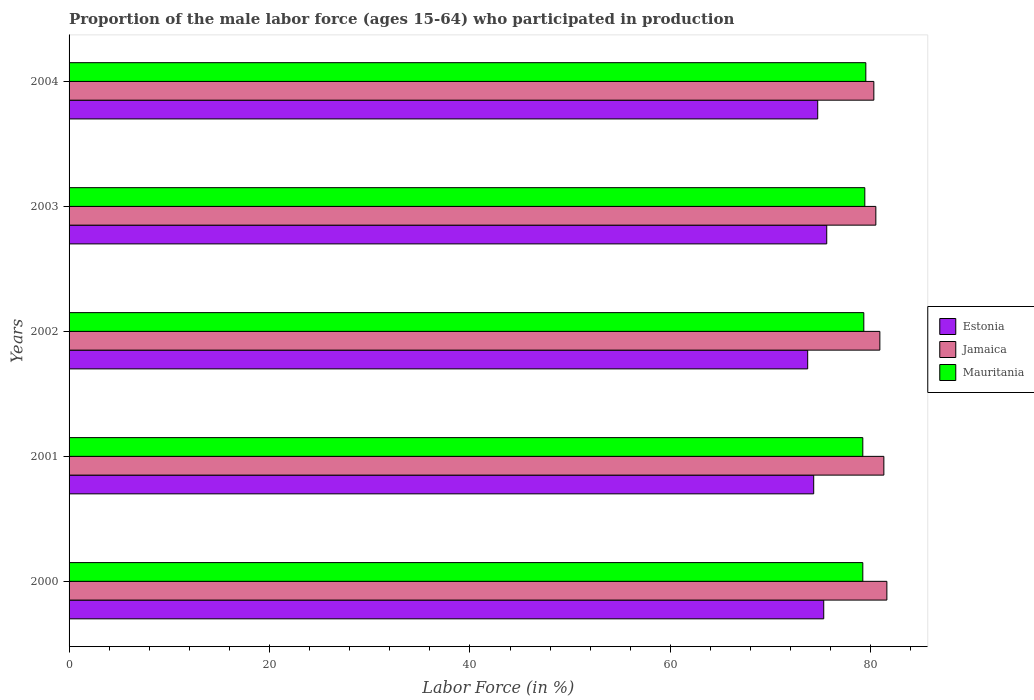How many different coloured bars are there?
Give a very brief answer. 3. How many groups of bars are there?
Offer a terse response. 5. How many bars are there on the 5th tick from the bottom?
Give a very brief answer. 3. What is the label of the 5th group of bars from the top?
Offer a terse response. 2000. What is the proportion of the male labor force who participated in production in Estonia in 2003?
Offer a very short reply. 75.6. Across all years, what is the maximum proportion of the male labor force who participated in production in Estonia?
Provide a succinct answer. 75.6. Across all years, what is the minimum proportion of the male labor force who participated in production in Estonia?
Your response must be concise. 73.7. In which year was the proportion of the male labor force who participated in production in Mauritania minimum?
Offer a very short reply. 2000. What is the total proportion of the male labor force who participated in production in Estonia in the graph?
Give a very brief answer. 373.6. What is the difference between the proportion of the male labor force who participated in production in Estonia in 2000 and that in 2002?
Give a very brief answer. 1.6. What is the difference between the proportion of the male labor force who participated in production in Mauritania in 2004 and the proportion of the male labor force who participated in production in Estonia in 2003?
Your response must be concise. 3.9. What is the average proportion of the male labor force who participated in production in Jamaica per year?
Make the answer very short. 80.92. In the year 2004, what is the difference between the proportion of the male labor force who participated in production in Jamaica and proportion of the male labor force who participated in production in Estonia?
Keep it short and to the point. 5.6. In how many years, is the proportion of the male labor force who participated in production in Jamaica greater than 32 %?
Your answer should be very brief. 5. What is the ratio of the proportion of the male labor force who participated in production in Estonia in 2000 to that in 2003?
Provide a short and direct response. 1. Is the proportion of the male labor force who participated in production in Estonia in 2000 less than that in 2003?
Your response must be concise. Yes. What is the difference between the highest and the second highest proportion of the male labor force who participated in production in Jamaica?
Offer a terse response. 0.3. What is the difference between the highest and the lowest proportion of the male labor force who participated in production in Jamaica?
Your answer should be very brief. 1.3. In how many years, is the proportion of the male labor force who participated in production in Jamaica greater than the average proportion of the male labor force who participated in production in Jamaica taken over all years?
Your response must be concise. 2. What does the 2nd bar from the top in 2000 represents?
Offer a terse response. Jamaica. What does the 1st bar from the bottom in 2003 represents?
Keep it short and to the point. Estonia. Is it the case that in every year, the sum of the proportion of the male labor force who participated in production in Mauritania and proportion of the male labor force who participated in production in Estonia is greater than the proportion of the male labor force who participated in production in Jamaica?
Keep it short and to the point. Yes. How many bars are there?
Your response must be concise. 15. Does the graph contain grids?
Your answer should be compact. No. How are the legend labels stacked?
Give a very brief answer. Vertical. What is the title of the graph?
Provide a succinct answer. Proportion of the male labor force (ages 15-64) who participated in production. What is the Labor Force (in %) in Estonia in 2000?
Your response must be concise. 75.3. What is the Labor Force (in %) in Jamaica in 2000?
Keep it short and to the point. 81.6. What is the Labor Force (in %) of Mauritania in 2000?
Make the answer very short. 79.2. What is the Labor Force (in %) of Estonia in 2001?
Provide a succinct answer. 74.3. What is the Labor Force (in %) of Jamaica in 2001?
Your response must be concise. 81.3. What is the Labor Force (in %) in Mauritania in 2001?
Offer a very short reply. 79.2. What is the Labor Force (in %) of Estonia in 2002?
Provide a short and direct response. 73.7. What is the Labor Force (in %) of Jamaica in 2002?
Give a very brief answer. 80.9. What is the Labor Force (in %) in Mauritania in 2002?
Make the answer very short. 79.3. What is the Labor Force (in %) in Estonia in 2003?
Make the answer very short. 75.6. What is the Labor Force (in %) in Jamaica in 2003?
Provide a succinct answer. 80.5. What is the Labor Force (in %) in Mauritania in 2003?
Keep it short and to the point. 79.4. What is the Labor Force (in %) of Estonia in 2004?
Offer a terse response. 74.7. What is the Labor Force (in %) in Jamaica in 2004?
Make the answer very short. 80.3. What is the Labor Force (in %) in Mauritania in 2004?
Provide a short and direct response. 79.5. Across all years, what is the maximum Labor Force (in %) of Estonia?
Ensure brevity in your answer.  75.6. Across all years, what is the maximum Labor Force (in %) of Jamaica?
Your answer should be compact. 81.6. Across all years, what is the maximum Labor Force (in %) of Mauritania?
Provide a succinct answer. 79.5. Across all years, what is the minimum Labor Force (in %) of Estonia?
Your answer should be very brief. 73.7. Across all years, what is the minimum Labor Force (in %) of Jamaica?
Ensure brevity in your answer.  80.3. Across all years, what is the minimum Labor Force (in %) of Mauritania?
Provide a succinct answer. 79.2. What is the total Labor Force (in %) in Estonia in the graph?
Keep it short and to the point. 373.6. What is the total Labor Force (in %) in Jamaica in the graph?
Your answer should be compact. 404.6. What is the total Labor Force (in %) in Mauritania in the graph?
Offer a very short reply. 396.6. What is the difference between the Labor Force (in %) of Jamaica in 2000 and that in 2001?
Your response must be concise. 0.3. What is the difference between the Labor Force (in %) in Estonia in 2000 and that in 2002?
Your answer should be compact. 1.6. What is the difference between the Labor Force (in %) in Jamaica in 2000 and that in 2003?
Your answer should be very brief. 1.1. What is the difference between the Labor Force (in %) of Mauritania in 2000 and that in 2003?
Give a very brief answer. -0.2. What is the difference between the Labor Force (in %) of Estonia in 2000 and that in 2004?
Ensure brevity in your answer.  0.6. What is the difference between the Labor Force (in %) of Jamaica in 2000 and that in 2004?
Provide a short and direct response. 1.3. What is the difference between the Labor Force (in %) of Estonia in 2001 and that in 2002?
Provide a succinct answer. 0.6. What is the difference between the Labor Force (in %) of Estonia in 2001 and that in 2003?
Provide a succinct answer. -1.3. What is the difference between the Labor Force (in %) in Mauritania in 2001 and that in 2003?
Keep it short and to the point. -0.2. What is the difference between the Labor Force (in %) of Estonia in 2001 and that in 2004?
Offer a terse response. -0.4. What is the difference between the Labor Force (in %) in Mauritania in 2001 and that in 2004?
Provide a succinct answer. -0.3. What is the difference between the Labor Force (in %) in Estonia in 2002 and that in 2003?
Provide a short and direct response. -1.9. What is the difference between the Labor Force (in %) in Mauritania in 2002 and that in 2003?
Give a very brief answer. -0.1. What is the difference between the Labor Force (in %) of Estonia in 2002 and that in 2004?
Make the answer very short. -1. What is the difference between the Labor Force (in %) of Jamaica in 2002 and that in 2004?
Ensure brevity in your answer.  0.6. What is the difference between the Labor Force (in %) in Mauritania in 2002 and that in 2004?
Offer a terse response. -0.2. What is the difference between the Labor Force (in %) in Estonia in 2003 and that in 2004?
Give a very brief answer. 0.9. What is the difference between the Labor Force (in %) of Jamaica in 2003 and that in 2004?
Your response must be concise. 0.2. What is the difference between the Labor Force (in %) in Jamaica in 2000 and the Labor Force (in %) in Mauritania in 2001?
Keep it short and to the point. 2.4. What is the difference between the Labor Force (in %) in Estonia in 2000 and the Labor Force (in %) in Mauritania in 2002?
Offer a very short reply. -4. What is the difference between the Labor Force (in %) in Estonia in 2000 and the Labor Force (in %) in Mauritania in 2003?
Provide a succinct answer. -4.1. What is the difference between the Labor Force (in %) in Jamaica in 2000 and the Labor Force (in %) in Mauritania in 2003?
Your answer should be compact. 2.2. What is the difference between the Labor Force (in %) in Estonia in 2000 and the Labor Force (in %) in Jamaica in 2004?
Your response must be concise. -5. What is the difference between the Labor Force (in %) in Jamaica in 2000 and the Labor Force (in %) in Mauritania in 2004?
Provide a succinct answer. 2.1. What is the difference between the Labor Force (in %) in Estonia in 2001 and the Labor Force (in %) in Jamaica in 2002?
Your answer should be very brief. -6.6. What is the difference between the Labor Force (in %) in Jamaica in 2001 and the Labor Force (in %) in Mauritania in 2002?
Give a very brief answer. 2. What is the difference between the Labor Force (in %) in Estonia in 2001 and the Labor Force (in %) in Mauritania in 2003?
Give a very brief answer. -5.1. What is the difference between the Labor Force (in %) of Jamaica in 2001 and the Labor Force (in %) of Mauritania in 2003?
Keep it short and to the point. 1.9. What is the difference between the Labor Force (in %) of Jamaica in 2001 and the Labor Force (in %) of Mauritania in 2004?
Ensure brevity in your answer.  1.8. What is the difference between the Labor Force (in %) of Estonia in 2003 and the Labor Force (in %) of Jamaica in 2004?
Give a very brief answer. -4.7. What is the difference between the Labor Force (in %) of Estonia in 2003 and the Labor Force (in %) of Mauritania in 2004?
Ensure brevity in your answer.  -3.9. What is the difference between the Labor Force (in %) in Jamaica in 2003 and the Labor Force (in %) in Mauritania in 2004?
Your answer should be very brief. 1. What is the average Labor Force (in %) of Estonia per year?
Keep it short and to the point. 74.72. What is the average Labor Force (in %) of Jamaica per year?
Ensure brevity in your answer.  80.92. What is the average Labor Force (in %) of Mauritania per year?
Your response must be concise. 79.32. In the year 2000, what is the difference between the Labor Force (in %) of Estonia and Labor Force (in %) of Jamaica?
Your response must be concise. -6.3. In the year 2000, what is the difference between the Labor Force (in %) of Estonia and Labor Force (in %) of Mauritania?
Your response must be concise. -3.9. In the year 2001, what is the difference between the Labor Force (in %) of Estonia and Labor Force (in %) of Jamaica?
Your response must be concise. -7. In the year 2002, what is the difference between the Labor Force (in %) of Estonia and Labor Force (in %) of Jamaica?
Your answer should be very brief. -7.2. In the year 2003, what is the difference between the Labor Force (in %) in Jamaica and Labor Force (in %) in Mauritania?
Your response must be concise. 1.1. In the year 2004, what is the difference between the Labor Force (in %) of Estonia and Labor Force (in %) of Mauritania?
Keep it short and to the point. -4.8. In the year 2004, what is the difference between the Labor Force (in %) in Jamaica and Labor Force (in %) in Mauritania?
Your answer should be very brief. 0.8. What is the ratio of the Labor Force (in %) in Estonia in 2000 to that in 2001?
Offer a very short reply. 1.01. What is the ratio of the Labor Force (in %) of Mauritania in 2000 to that in 2001?
Make the answer very short. 1. What is the ratio of the Labor Force (in %) in Estonia in 2000 to that in 2002?
Ensure brevity in your answer.  1.02. What is the ratio of the Labor Force (in %) of Jamaica in 2000 to that in 2002?
Your answer should be very brief. 1.01. What is the ratio of the Labor Force (in %) of Estonia in 2000 to that in 2003?
Offer a very short reply. 1. What is the ratio of the Labor Force (in %) of Jamaica in 2000 to that in 2003?
Ensure brevity in your answer.  1.01. What is the ratio of the Labor Force (in %) of Jamaica in 2000 to that in 2004?
Ensure brevity in your answer.  1.02. What is the ratio of the Labor Force (in %) in Mauritania in 2000 to that in 2004?
Provide a short and direct response. 1. What is the ratio of the Labor Force (in %) of Estonia in 2001 to that in 2002?
Make the answer very short. 1.01. What is the ratio of the Labor Force (in %) of Jamaica in 2001 to that in 2002?
Provide a short and direct response. 1. What is the ratio of the Labor Force (in %) of Estonia in 2001 to that in 2003?
Ensure brevity in your answer.  0.98. What is the ratio of the Labor Force (in %) of Jamaica in 2001 to that in 2003?
Provide a succinct answer. 1.01. What is the ratio of the Labor Force (in %) of Mauritania in 2001 to that in 2003?
Your response must be concise. 1. What is the ratio of the Labor Force (in %) of Estonia in 2001 to that in 2004?
Offer a very short reply. 0.99. What is the ratio of the Labor Force (in %) of Jamaica in 2001 to that in 2004?
Keep it short and to the point. 1.01. What is the ratio of the Labor Force (in %) of Estonia in 2002 to that in 2003?
Give a very brief answer. 0.97. What is the ratio of the Labor Force (in %) of Mauritania in 2002 to that in 2003?
Keep it short and to the point. 1. What is the ratio of the Labor Force (in %) in Estonia in 2002 to that in 2004?
Your response must be concise. 0.99. What is the ratio of the Labor Force (in %) in Jamaica in 2002 to that in 2004?
Provide a short and direct response. 1.01. What is the difference between the highest and the second highest Labor Force (in %) in Jamaica?
Offer a terse response. 0.3. What is the difference between the highest and the lowest Labor Force (in %) of Jamaica?
Your response must be concise. 1.3. 